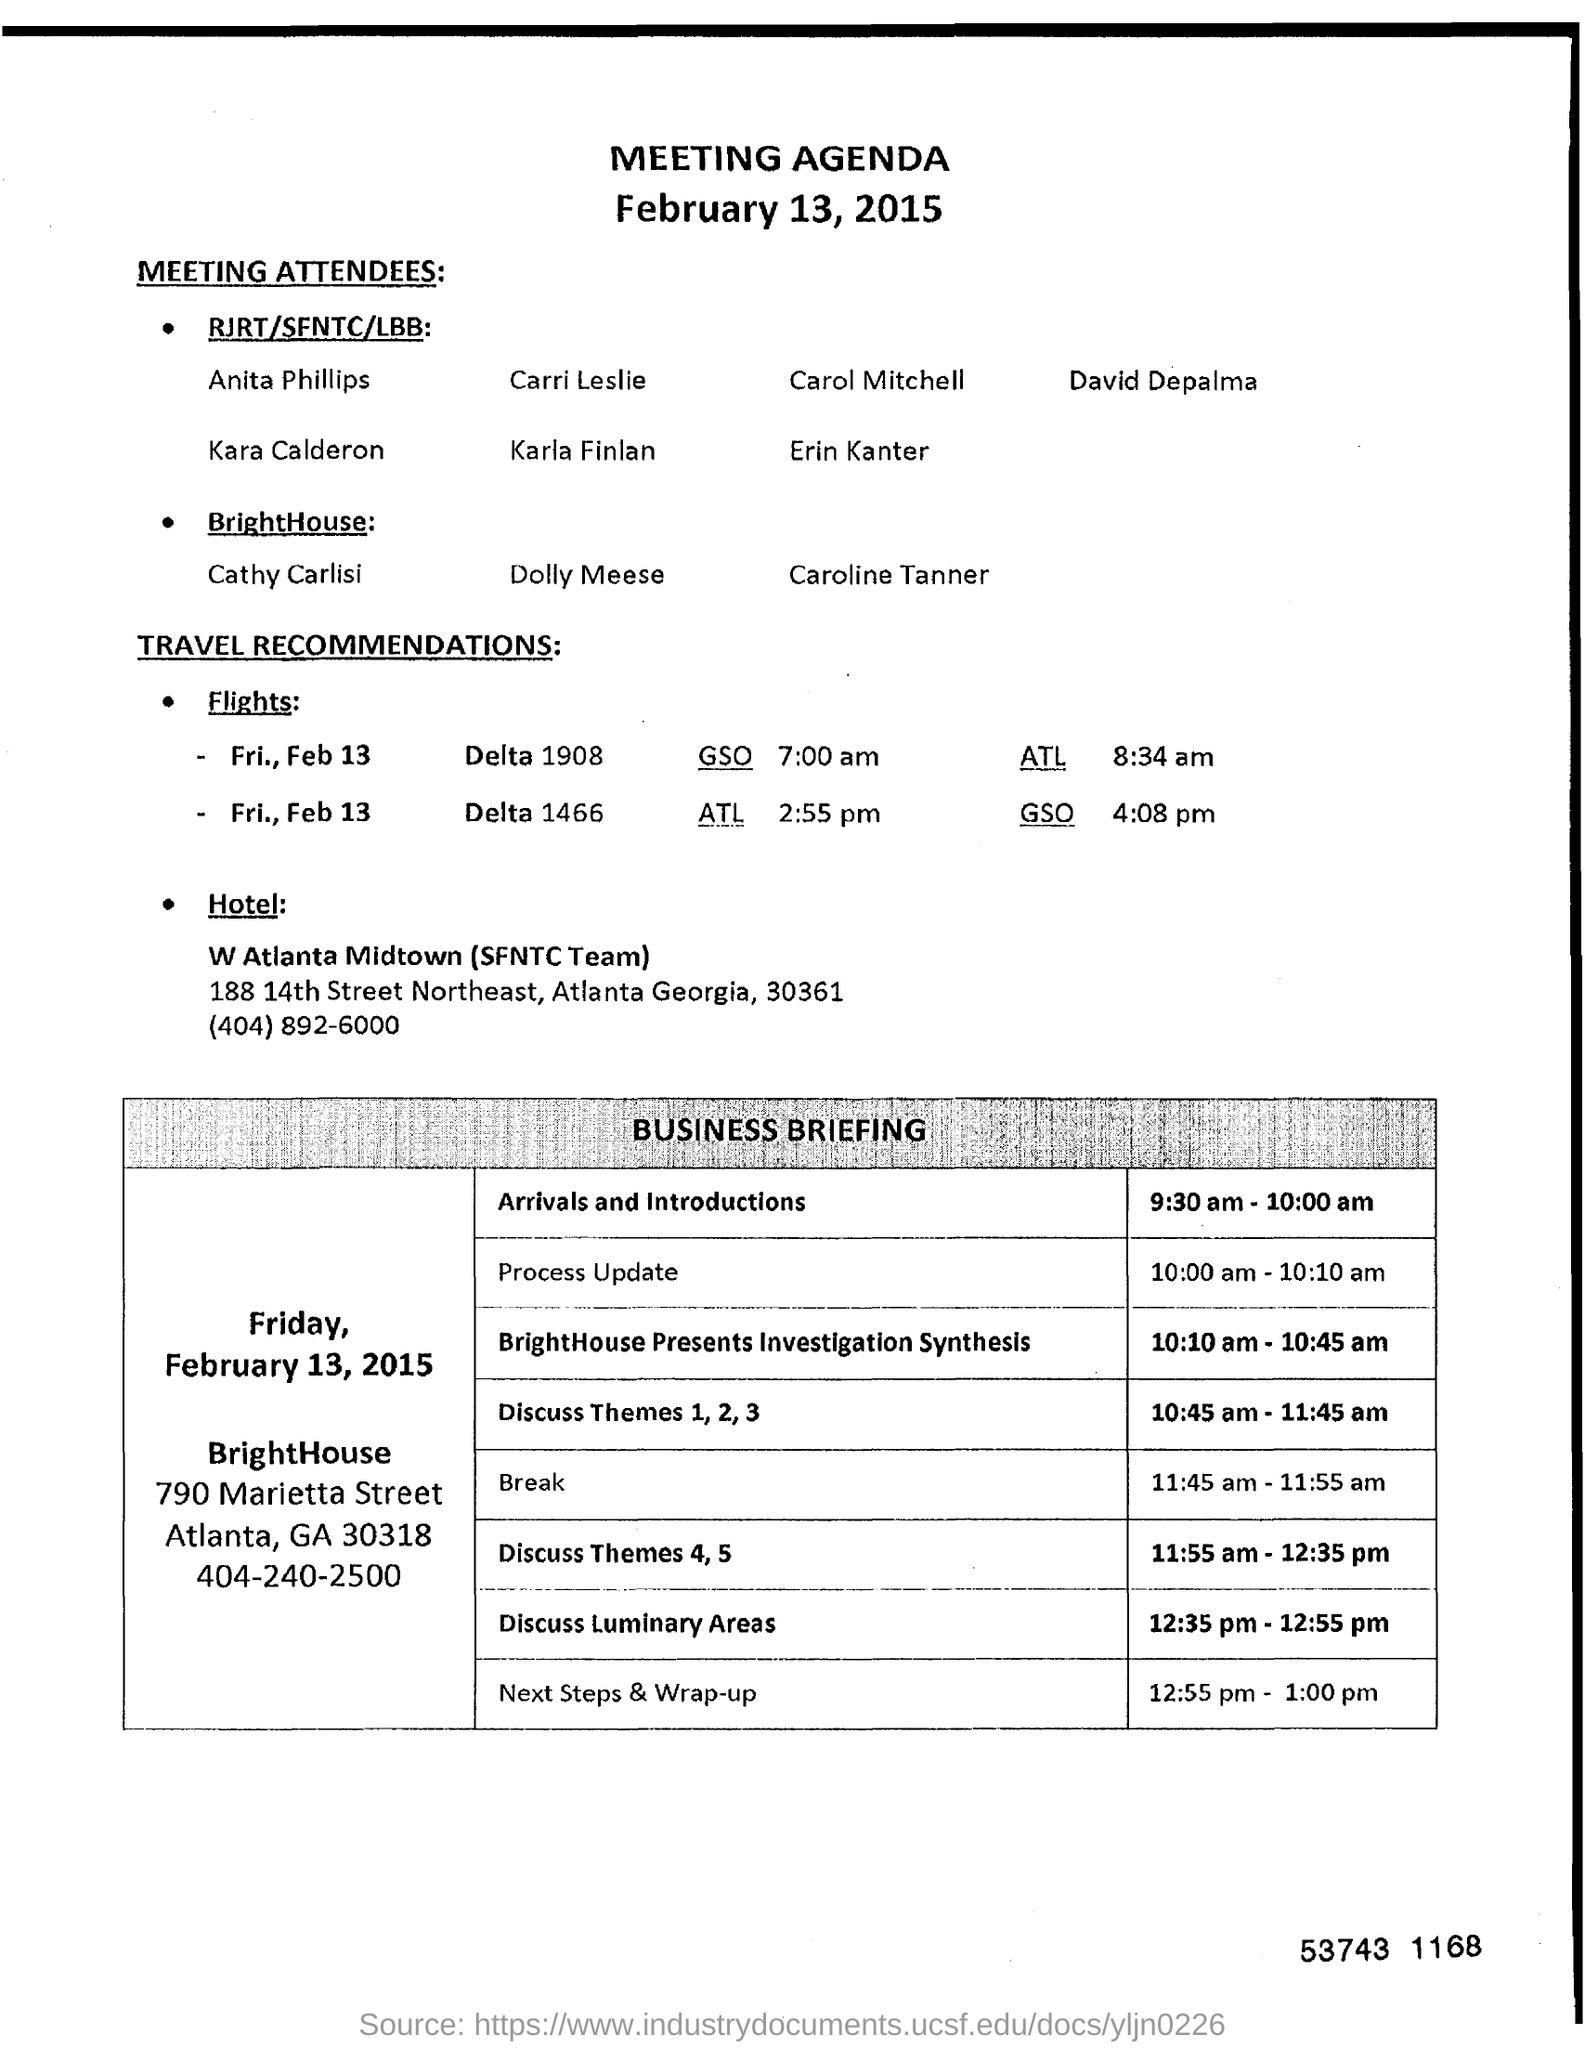When is the meeting?
Keep it short and to the point. February 13, 2015. What time is the Process Update scheduled?
Your answer should be very brief. 10:00 am - 10:10 am. 